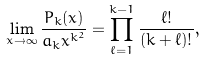Convert formula to latex. <formula><loc_0><loc_0><loc_500><loc_500>\lim _ { x \rightarrow \infty } \frac { P _ { k } ( x ) } { a _ { k } x ^ { k ^ { 2 } } } = \prod _ { \ell = 1 } ^ { k - 1 } \frac { \ell ! } { ( k + \ell ) ! } ,</formula> 